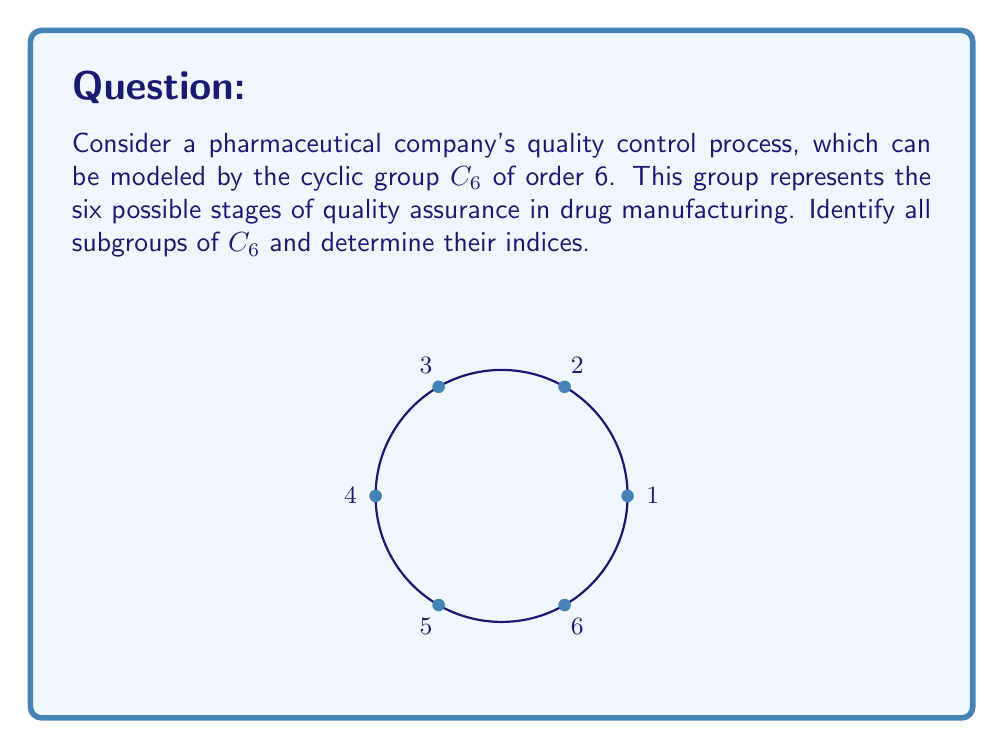What is the answer to this math problem? Let's approach this step-by-step:

1) First, recall that $C_6 = \{e, a, a^2, a^3, a^4, a^5\}$, where $e$ is the identity element and $a$ is a generator of the group.

2) To find subgroups, we need to consider elements that, when repeatedly applied, generate a subset of $C_6$ that is closed under the group operation.

3) The trivial subgroups are always present:
   - $\{e\}$: the identity subgroup
   - $C_6$ itself

4) For non-trivial proper subgroups, we consider the cyclic subgroups generated by each element:
   - $\langle a \rangle = C_6$
   - $\langle a^2 \rangle = \{e, a^2, a^4\}$
   - $\langle a^3 \rangle = \{e, a^3\}$
   - $\langle a^4 \rangle = \{e, a^2, a^4\}$ (same as $\langle a^2 \rangle$)
   - $\langle a^5 \rangle = C_6$

5) Thus, we have identified all subgroups:
   - $H_1 = \{e\}$
   - $H_2 = \{e, a^3\}$
   - $H_3 = \{e, a^2, a^4\}$
   - $H_4 = C_6$

6) To determine the index of each subgroup, we use the formula:
   $[G:H] = \frac{|G|}{|H|}$, where $|G|$ is the order of $C_6$ (which is 6) and $|H|$ is the order of the subgroup.

   - For $H_1$: $[C_6:H_1] = \frac{6}{1} = 6$
   - For $H_2$: $[C_6:H_2] = \frac{6}{2} = 3$
   - For $H_3$: $[C_6:H_3] = \frac{6}{3} = 2$
   - For $H_4$: $[C_6:H_4] = \frac{6}{6} = 1$
Answer: Subgroups: $\{e\}$, $\{e, a^3\}$, $\{e, a^2, a^4\}$, $C_6$. Indices: 6, 3, 2, 1 respectively. 